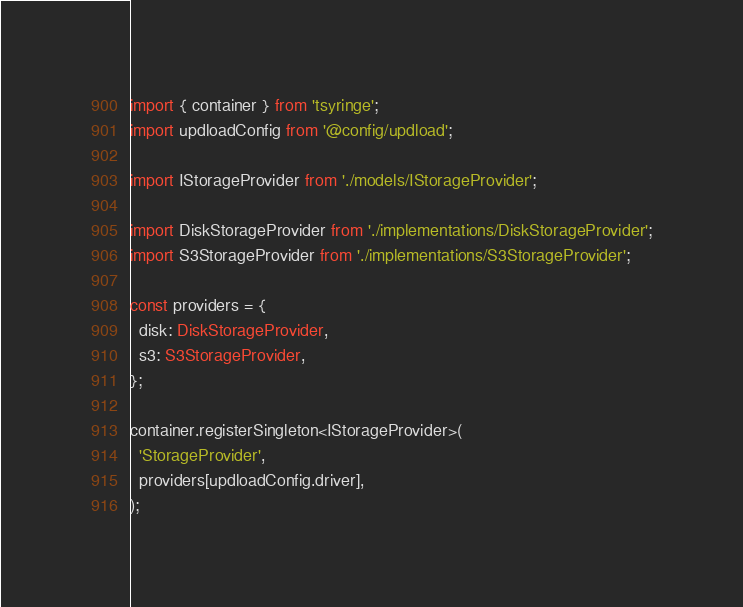Convert code to text. <code><loc_0><loc_0><loc_500><loc_500><_TypeScript_>import { container } from 'tsyringe';
import updloadConfig from '@config/updload';

import IStorageProvider from './models/IStorageProvider';

import DiskStorageProvider from './implementations/DiskStorageProvider';
import S3StorageProvider from './implementations/S3StorageProvider';

const providers = {
  disk: DiskStorageProvider,
  s3: S3StorageProvider,
};

container.registerSingleton<IStorageProvider>(
  'StorageProvider',
  providers[updloadConfig.driver],
);
</code> 